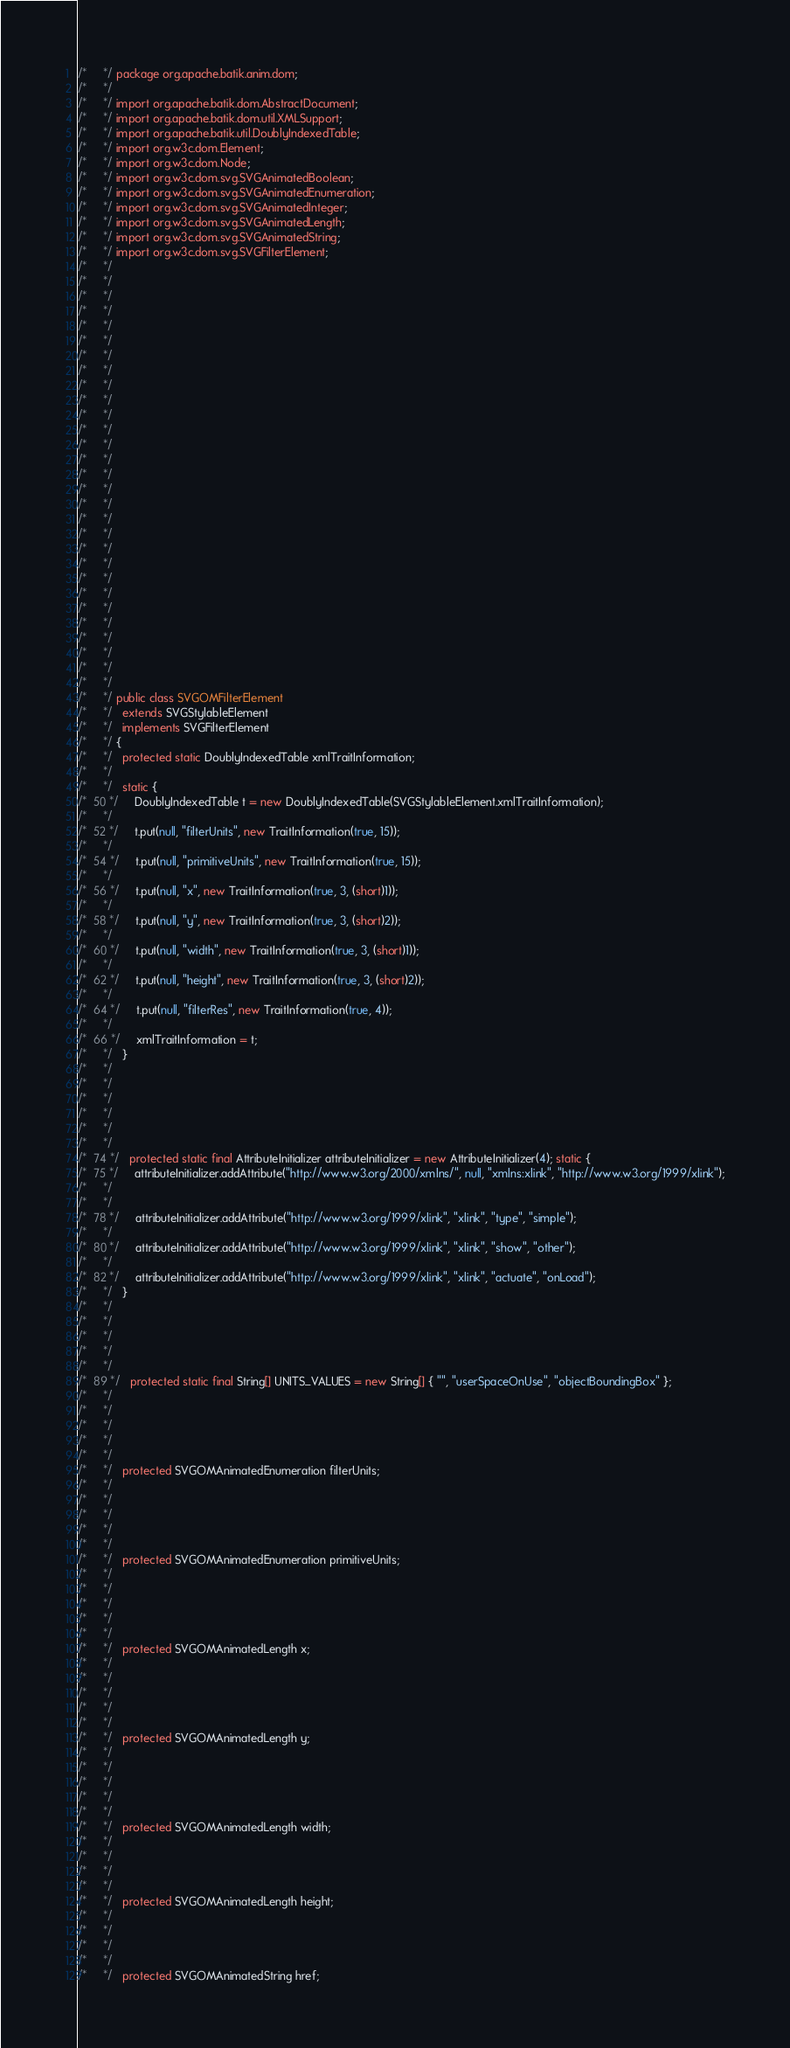<code> <loc_0><loc_0><loc_500><loc_500><_Java_>/*     */ package org.apache.batik.anim.dom;
/*     */ 
/*     */ import org.apache.batik.dom.AbstractDocument;
/*     */ import org.apache.batik.dom.util.XMLSupport;
/*     */ import org.apache.batik.util.DoublyIndexedTable;
/*     */ import org.w3c.dom.Element;
/*     */ import org.w3c.dom.Node;
/*     */ import org.w3c.dom.svg.SVGAnimatedBoolean;
/*     */ import org.w3c.dom.svg.SVGAnimatedEnumeration;
/*     */ import org.w3c.dom.svg.SVGAnimatedInteger;
/*     */ import org.w3c.dom.svg.SVGAnimatedLength;
/*     */ import org.w3c.dom.svg.SVGAnimatedString;
/*     */ import org.w3c.dom.svg.SVGFilterElement;
/*     */ 
/*     */ 
/*     */ 
/*     */ 
/*     */ 
/*     */ 
/*     */ 
/*     */ 
/*     */ 
/*     */ 
/*     */ 
/*     */ 
/*     */ 
/*     */ 
/*     */ 
/*     */ 
/*     */ 
/*     */ 
/*     */ 
/*     */ 
/*     */ 
/*     */ 
/*     */ 
/*     */ 
/*     */ 
/*     */ 
/*     */ 
/*     */ 
/*     */ 
/*     */ public class SVGOMFilterElement
/*     */   extends SVGStylableElement
/*     */   implements SVGFilterElement
/*     */ {
/*     */   protected static DoublyIndexedTable xmlTraitInformation;
/*     */   
/*     */   static {
/*  50 */     DoublyIndexedTable t = new DoublyIndexedTable(SVGStylableElement.xmlTraitInformation);
/*     */     
/*  52 */     t.put(null, "filterUnits", new TraitInformation(true, 15));
/*     */     
/*  54 */     t.put(null, "primitiveUnits", new TraitInformation(true, 15));
/*     */     
/*  56 */     t.put(null, "x", new TraitInformation(true, 3, (short)1));
/*     */     
/*  58 */     t.put(null, "y", new TraitInformation(true, 3, (short)2));
/*     */     
/*  60 */     t.put(null, "width", new TraitInformation(true, 3, (short)1));
/*     */     
/*  62 */     t.put(null, "height", new TraitInformation(true, 3, (short)2));
/*     */     
/*  64 */     t.put(null, "filterRes", new TraitInformation(true, 4));
/*     */     
/*  66 */     xmlTraitInformation = t;
/*     */   }
/*     */ 
/*     */ 
/*     */ 
/*     */ 
/*     */ 
/*     */   
/*  74 */   protected static final AttributeInitializer attributeInitializer = new AttributeInitializer(4); static {
/*  75 */     attributeInitializer.addAttribute("http://www.w3.org/2000/xmlns/", null, "xmlns:xlink", "http://www.w3.org/1999/xlink");
/*     */ 
/*     */     
/*  78 */     attributeInitializer.addAttribute("http://www.w3.org/1999/xlink", "xlink", "type", "simple");
/*     */     
/*  80 */     attributeInitializer.addAttribute("http://www.w3.org/1999/xlink", "xlink", "show", "other");
/*     */     
/*  82 */     attributeInitializer.addAttribute("http://www.w3.org/1999/xlink", "xlink", "actuate", "onLoad");
/*     */   }
/*     */ 
/*     */ 
/*     */ 
/*     */ 
/*     */   
/*  89 */   protected static final String[] UNITS_VALUES = new String[] { "", "userSpaceOnUse", "objectBoundingBox" };
/*     */ 
/*     */ 
/*     */ 
/*     */ 
/*     */   
/*     */   protected SVGOMAnimatedEnumeration filterUnits;
/*     */ 
/*     */ 
/*     */ 
/*     */ 
/*     */   
/*     */   protected SVGOMAnimatedEnumeration primitiveUnits;
/*     */ 
/*     */ 
/*     */ 
/*     */ 
/*     */   
/*     */   protected SVGOMAnimatedLength x;
/*     */ 
/*     */ 
/*     */ 
/*     */ 
/*     */   
/*     */   protected SVGOMAnimatedLength y;
/*     */ 
/*     */ 
/*     */ 
/*     */ 
/*     */   
/*     */   protected SVGOMAnimatedLength width;
/*     */ 
/*     */ 
/*     */ 
/*     */   
/*     */   protected SVGOMAnimatedLength height;
/*     */ 
/*     */ 
/*     */ 
/*     */   
/*     */   protected SVGOMAnimatedString href;</code> 